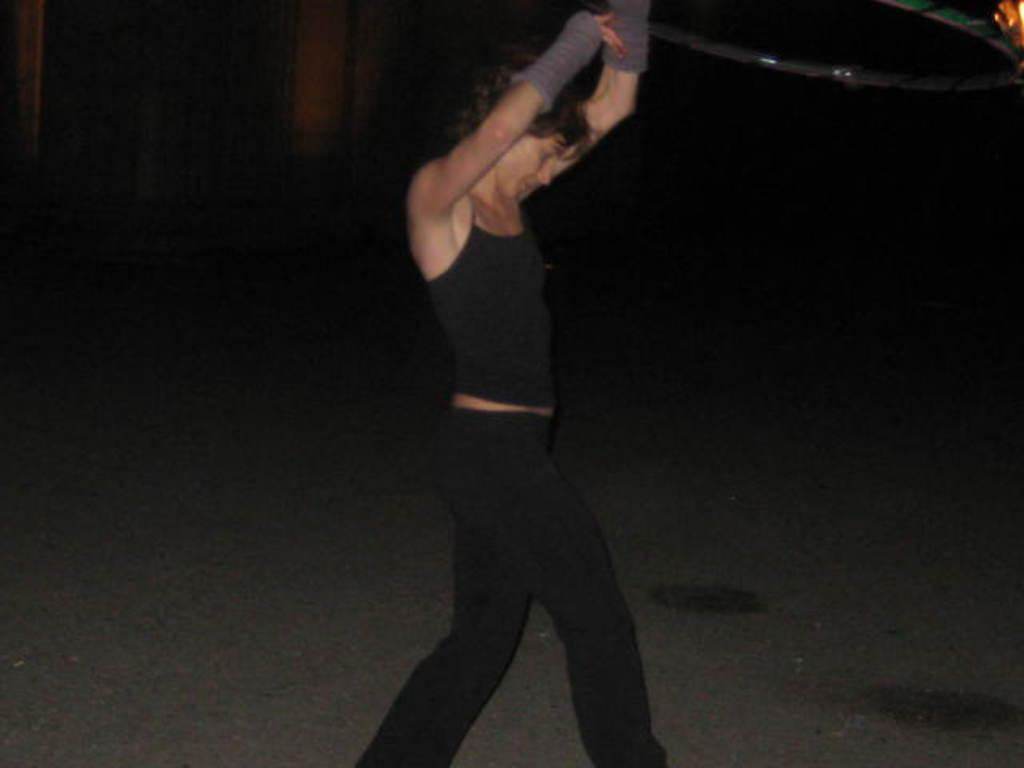Who is the main subject in the image? There is a woman in the image. What is the woman wearing? The woman is wearing a black dress. What is the woman doing in the image? The woman is dancing. What else can be seen in the background of the image? There are other objects in the background of the image. What is the smell of the gold in the image? There is no gold present in the image, so it is not possible to determine its smell. 